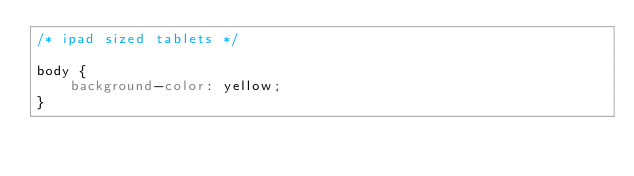Convert code to text. <code><loc_0><loc_0><loc_500><loc_500><_CSS_>/* ipad sized tablets */

body {
	background-color: yellow;
}</code> 